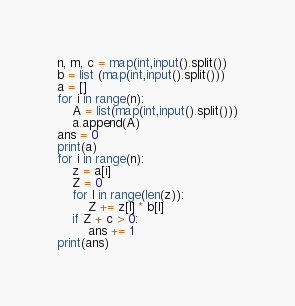<code> <loc_0><loc_0><loc_500><loc_500><_Python_>n, m, c = map(int,input().split())
b = list (map(int,input().split()))
a = []
for i in range(n):
    A = list(map(int,input().split()))
    a.append(A)
ans = 0
print(a)
for i in range(n):
    z = a[i]
    Z = 0
    for l in range(len(z)):
        Z += z[l] * b[l]
    if Z + c > 0:
        ans += 1
print(ans)</code> 